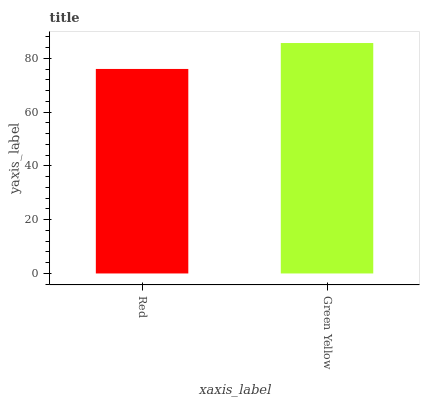Is Red the minimum?
Answer yes or no. Yes. Is Green Yellow the maximum?
Answer yes or no. Yes. Is Green Yellow the minimum?
Answer yes or no. No. Is Green Yellow greater than Red?
Answer yes or no. Yes. Is Red less than Green Yellow?
Answer yes or no. Yes. Is Red greater than Green Yellow?
Answer yes or no. No. Is Green Yellow less than Red?
Answer yes or no. No. Is Green Yellow the high median?
Answer yes or no. Yes. Is Red the low median?
Answer yes or no. Yes. Is Red the high median?
Answer yes or no. No. Is Green Yellow the low median?
Answer yes or no. No. 